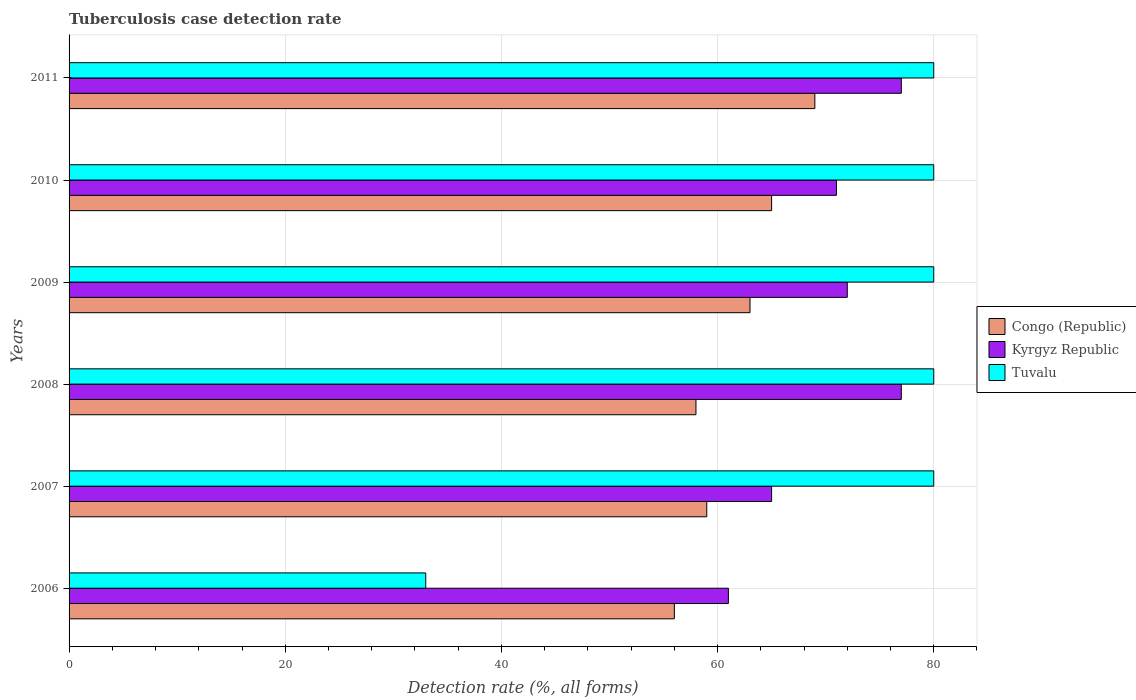How many different coloured bars are there?
Ensure brevity in your answer.  3. How many groups of bars are there?
Make the answer very short. 6. Are the number of bars per tick equal to the number of legend labels?
Keep it short and to the point. Yes. Are the number of bars on each tick of the Y-axis equal?
Provide a succinct answer. Yes. How many bars are there on the 3rd tick from the bottom?
Provide a succinct answer. 3. What is the label of the 4th group of bars from the top?
Make the answer very short. 2008. Across all years, what is the maximum tuberculosis case detection rate in in Kyrgyz Republic?
Your answer should be very brief. 77. Across all years, what is the minimum tuberculosis case detection rate in in Congo (Republic)?
Your answer should be very brief. 56. In which year was the tuberculosis case detection rate in in Tuvalu maximum?
Your response must be concise. 2007. In which year was the tuberculosis case detection rate in in Kyrgyz Republic minimum?
Give a very brief answer. 2006. What is the total tuberculosis case detection rate in in Tuvalu in the graph?
Keep it short and to the point. 433. What is the difference between the tuberculosis case detection rate in in Tuvalu in 2006 and the tuberculosis case detection rate in in Kyrgyz Republic in 2009?
Your answer should be very brief. -39. What is the average tuberculosis case detection rate in in Congo (Republic) per year?
Your answer should be very brief. 61.67. What is the ratio of the tuberculosis case detection rate in in Congo (Republic) in 2006 to that in 2007?
Keep it short and to the point. 0.95. What is the difference between the highest and the second highest tuberculosis case detection rate in in Congo (Republic)?
Your answer should be very brief. 4. What is the difference between the highest and the lowest tuberculosis case detection rate in in Congo (Republic)?
Keep it short and to the point. 13. In how many years, is the tuberculosis case detection rate in in Kyrgyz Republic greater than the average tuberculosis case detection rate in in Kyrgyz Republic taken over all years?
Your answer should be very brief. 4. What does the 2nd bar from the top in 2007 represents?
Your answer should be compact. Kyrgyz Republic. What does the 3rd bar from the bottom in 2009 represents?
Your answer should be very brief. Tuvalu. Is it the case that in every year, the sum of the tuberculosis case detection rate in in Tuvalu and tuberculosis case detection rate in in Kyrgyz Republic is greater than the tuberculosis case detection rate in in Congo (Republic)?
Your answer should be compact. Yes. How many bars are there?
Make the answer very short. 18. Are all the bars in the graph horizontal?
Keep it short and to the point. Yes. What is the difference between two consecutive major ticks on the X-axis?
Provide a succinct answer. 20. Are the values on the major ticks of X-axis written in scientific E-notation?
Your response must be concise. No. Does the graph contain any zero values?
Ensure brevity in your answer.  No. Does the graph contain grids?
Make the answer very short. Yes. Where does the legend appear in the graph?
Your answer should be compact. Center right. What is the title of the graph?
Offer a terse response. Tuberculosis case detection rate. Does "European Union" appear as one of the legend labels in the graph?
Provide a short and direct response. No. What is the label or title of the X-axis?
Keep it short and to the point. Detection rate (%, all forms). What is the label or title of the Y-axis?
Give a very brief answer. Years. What is the Detection rate (%, all forms) of Kyrgyz Republic in 2006?
Your answer should be compact. 61. What is the Detection rate (%, all forms) in Tuvalu in 2006?
Ensure brevity in your answer.  33. What is the Detection rate (%, all forms) of Congo (Republic) in 2009?
Keep it short and to the point. 63. What is the Detection rate (%, all forms) of Kyrgyz Republic in 2009?
Ensure brevity in your answer.  72. What is the Detection rate (%, all forms) in Tuvalu in 2009?
Ensure brevity in your answer.  80. What is the Detection rate (%, all forms) in Kyrgyz Republic in 2010?
Your answer should be compact. 71. What is the Detection rate (%, all forms) of Tuvalu in 2011?
Make the answer very short. 80. Across all years, what is the maximum Detection rate (%, all forms) in Kyrgyz Republic?
Make the answer very short. 77. Across all years, what is the minimum Detection rate (%, all forms) in Tuvalu?
Make the answer very short. 33. What is the total Detection rate (%, all forms) in Congo (Republic) in the graph?
Your response must be concise. 370. What is the total Detection rate (%, all forms) in Kyrgyz Republic in the graph?
Provide a short and direct response. 423. What is the total Detection rate (%, all forms) of Tuvalu in the graph?
Offer a terse response. 433. What is the difference between the Detection rate (%, all forms) in Congo (Republic) in 2006 and that in 2007?
Your answer should be very brief. -3. What is the difference between the Detection rate (%, all forms) of Kyrgyz Republic in 2006 and that in 2007?
Keep it short and to the point. -4. What is the difference between the Detection rate (%, all forms) of Tuvalu in 2006 and that in 2007?
Give a very brief answer. -47. What is the difference between the Detection rate (%, all forms) in Kyrgyz Republic in 2006 and that in 2008?
Keep it short and to the point. -16. What is the difference between the Detection rate (%, all forms) of Tuvalu in 2006 and that in 2008?
Give a very brief answer. -47. What is the difference between the Detection rate (%, all forms) in Congo (Republic) in 2006 and that in 2009?
Make the answer very short. -7. What is the difference between the Detection rate (%, all forms) of Tuvalu in 2006 and that in 2009?
Your answer should be very brief. -47. What is the difference between the Detection rate (%, all forms) in Kyrgyz Republic in 2006 and that in 2010?
Offer a very short reply. -10. What is the difference between the Detection rate (%, all forms) in Tuvalu in 2006 and that in 2010?
Provide a short and direct response. -47. What is the difference between the Detection rate (%, all forms) of Tuvalu in 2006 and that in 2011?
Provide a short and direct response. -47. What is the difference between the Detection rate (%, all forms) in Congo (Republic) in 2007 and that in 2008?
Keep it short and to the point. 1. What is the difference between the Detection rate (%, all forms) in Kyrgyz Republic in 2007 and that in 2008?
Offer a terse response. -12. What is the difference between the Detection rate (%, all forms) in Congo (Republic) in 2007 and that in 2009?
Offer a terse response. -4. What is the difference between the Detection rate (%, all forms) in Kyrgyz Republic in 2007 and that in 2009?
Offer a terse response. -7. What is the difference between the Detection rate (%, all forms) in Tuvalu in 2007 and that in 2009?
Offer a very short reply. 0. What is the difference between the Detection rate (%, all forms) in Tuvalu in 2007 and that in 2010?
Offer a very short reply. 0. What is the difference between the Detection rate (%, all forms) of Congo (Republic) in 2007 and that in 2011?
Offer a terse response. -10. What is the difference between the Detection rate (%, all forms) of Kyrgyz Republic in 2007 and that in 2011?
Ensure brevity in your answer.  -12. What is the difference between the Detection rate (%, all forms) of Tuvalu in 2008 and that in 2009?
Keep it short and to the point. 0. What is the difference between the Detection rate (%, all forms) of Congo (Republic) in 2008 and that in 2010?
Offer a terse response. -7. What is the difference between the Detection rate (%, all forms) of Congo (Republic) in 2008 and that in 2011?
Provide a short and direct response. -11. What is the difference between the Detection rate (%, all forms) of Tuvalu in 2008 and that in 2011?
Keep it short and to the point. 0. What is the difference between the Detection rate (%, all forms) of Congo (Republic) in 2009 and that in 2011?
Provide a short and direct response. -6. What is the difference between the Detection rate (%, all forms) in Kyrgyz Republic in 2009 and that in 2011?
Your answer should be compact. -5. What is the difference between the Detection rate (%, all forms) of Tuvalu in 2009 and that in 2011?
Make the answer very short. 0. What is the difference between the Detection rate (%, all forms) in Congo (Republic) in 2010 and that in 2011?
Provide a succinct answer. -4. What is the difference between the Detection rate (%, all forms) of Tuvalu in 2010 and that in 2011?
Make the answer very short. 0. What is the difference between the Detection rate (%, all forms) of Kyrgyz Republic in 2006 and the Detection rate (%, all forms) of Tuvalu in 2007?
Ensure brevity in your answer.  -19. What is the difference between the Detection rate (%, all forms) of Congo (Republic) in 2006 and the Detection rate (%, all forms) of Kyrgyz Republic in 2008?
Offer a terse response. -21. What is the difference between the Detection rate (%, all forms) of Congo (Republic) in 2006 and the Detection rate (%, all forms) of Tuvalu in 2008?
Offer a terse response. -24. What is the difference between the Detection rate (%, all forms) of Kyrgyz Republic in 2006 and the Detection rate (%, all forms) of Tuvalu in 2009?
Keep it short and to the point. -19. What is the difference between the Detection rate (%, all forms) in Kyrgyz Republic in 2006 and the Detection rate (%, all forms) in Tuvalu in 2010?
Your answer should be very brief. -19. What is the difference between the Detection rate (%, all forms) of Congo (Republic) in 2006 and the Detection rate (%, all forms) of Kyrgyz Republic in 2011?
Offer a terse response. -21. What is the difference between the Detection rate (%, all forms) of Congo (Republic) in 2006 and the Detection rate (%, all forms) of Tuvalu in 2011?
Your response must be concise. -24. What is the difference between the Detection rate (%, all forms) in Congo (Republic) in 2007 and the Detection rate (%, all forms) in Kyrgyz Republic in 2009?
Provide a short and direct response. -13. What is the difference between the Detection rate (%, all forms) of Congo (Republic) in 2007 and the Detection rate (%, all forms) of Tuvalu in 2009?
Keep it short and to the point. -21. What is the difference between the Detection rate (%, all forms) in Kyrgyz Republic in 2007 and the Detection rate (%, all forms) in Tuvalu in 2009?
Ensure brevity in your answer.  -15. What is the difference between the Detection rate (%, all forms) of Kyrgyz Republic in 2007 and the Detection rate (%, all forms) of Tuvalu in 2010?
Your response must be concise. -15. What is the difference between the Detection rate (%, all forms) in Congo (Republic) in 2007 and the Detection rate (%, all forms) in Tuvalu in 2011?
Your response must be concise. -21. What is the difference between the Detection rate (%, all forms) of Congo (Republic) in 2008 and the Detection rate (%, all forms) of Kyrgyz Republic in 2009?
Give a very brief answer. -14. What is the difference between the Detection rate (%, all forms) in Kyrgyz Republic in 2008 and the Detection rate (%, all forms) in Tuvalu in 2009?
Provide a short and direct response. -3. What is the difference between the Detection rate (%, all forms) of Congo (Republic) in 2008 and the Detection rate (%, all forms) of Tuvalu in 2010?
Your answer should be very brief. -22. What is the difference between the Detection rate (%, all forms) of Congo (Republic) in 2008 and the Detection rate (%, all forms) of Tuvalu in 2011?
Your answer should be very brief. -22. What is the difference between the Detection rate (%, all forms) in Kyrgyz Republic in 2008 and the Detection rate (%, all forms) in Tuvalu in 2011?
Provide a short and direct response. -3. What is the difference between the Detection rate (%, all forms) in Congo (Republic) in 2009 and the Detection rate (%, all forms) in Tuvalu in 2010?
Provide a succinct answer. -17. What is the difference between the Detection rate (%, all forms) in Congo (Republic) in 2009 and the Detection rate (%, all forms) in Kyrgyz Republic in 2011?
Give a very brief answer. -14. What is the difference between the Detection rate (%, all forms) of Congo (Republic) in 2010 and the Detection rate (%, all forms) of Kyrgyz Republic in 2011?
Make the answer very short. -12. What is the average Detection rate (%, all forms) of Congo (Republic) per year?
Keep it short and to the point. 61.67. What is the average Detection rate (%, all forms) of Kyrgyz Republic per year?
Make the answer very short. 70.5. What is the average Detection rate (%, all forms) of Tuvalu per year?
Your response must be concise. 72.17. In the year 2006, what is the difference between the Detection rate (%, all forms) of Congo (Republic) and Detection rate (%, all forms) of Kyrgyz Republic?
Your answer should be very brief. -5. In the year 2007, what is the difference between the Detection rate (%, all forms) in Kyrgyz Republic and Detection rate (%, all forms) in Tuvalu?
Offer a very short reply. -15. In the year 2008, what is the difference between the Detection rate (%, all forms) in Congo (Republic) and Detection rate (%, all forms) in Kyrgyz Republic?
Provide a succinct answer. -19. In the year 2009, what is the difference between the Detection rate (%, all forms) in Congo (Republic) and Detection rate (%, all forms) in Kyrgyz Republic?
Provide a succinct answer. -9. In the year 2009, what is the difference between the Detection rate (%, all forms) of Congo (Republic) and Detection rate (%, all forms) of Tuvalu?
Ensure brevity in your answer.  -17. In the year 2010, what is the difference between the Detection rate (%, all forms) of Congo (Republic) and Detection rate (%, all forms) of Tuvalu?
Your response must be concise. -15. In the year 2011, what is the difference between the Detection rate (%, all forms) of Congo (Republic) and Detection rate (%, all forms) of Kyrgyz Republic?
Offer a terse response. -8. In the year 2011, what is the difference between the Detection rate (%, all forms) of Congo (Republic) and Detection rate (%, all forms) of Tuvalu?
Offer a very short reply. -11. In the year 2011, what is the difference between the Detection rate (%, all forms) in Kyrgyz Republic and Detection rate (%, all forms) in Tuvalu?
Offer a very short reply. -3. What is the ratio of the Detection rate (%, all forms) of Congo (Republic) in 2006 to that in 2007?
Your answer should be very brief. 0.95. What is the ratio of the Detection rate (%, all forms) in Kyrgyz Republic in 2006 to that in 2007?
Keep it short and to the point. 0.94. What is the ratio of the Detection rate (%, all forms) of Tuvalu in 2006 to that in 2007?
Ensure brevity in your answer.  0.41. What is the ratio of the Detection rate (%, all forms) of Congo (Republic) in 2006 to that in 2008?
Make the answer very short. 0.97. What is the ratio of the Detection rate (%, all forms) of Kyrgyz Republic in 2006 to that in 2008?
Make the answer very short. 0.79. What is the ratio of the Detection rate (%, all forms) of Tuvalu in 2006 to that in 2008?
Your answer should be compact. 0.41. What is the ratio of the Detection rate (%, all forms) of Kyrgyz Republic in 2006 to that in 2009?
Offer a very short reply. 0.85. What is the ratio of the Detection rate (%, all forms) of Tuvalu in 2006 to that in 2009?
Provide a short and direct response. 0.41. What is the ratio of the Detection rate (%, all forms) in Congo (Republic) in 2006 to that in 2010?
Ensure brevity in your answer.  0.86. What is the ratio of the Detection rate (%, all forms) of Kyrgyz Republic in 2006 to that in 2010?
Offer a terse response. 0.86. What is the ratio of the Detection rate (%, all forms) in Tuvalu in 2006 to that in 2010?
Provide a short and direct response. 0.41. What is the ratio of the Detection rate (%, all forms) of Congo (Republic) in 2006 to that in 2011?
Make the answer very short. 0.81. What is the ratio of the Detection rate (%, all forms) in Kyrgyz Republic in 2006 to that in 2011?
Offer a very short reply. 0.79. What is the ratio of the Detection rate (%, all forms) in Tuvalu in 2006 to that in 2011?
Offer a terse response. 0.41. What is the ratio of the Detection rate (%, all forms) of Congo (Republic) in 2007 to that in 2008?
Ensure brevity in your answer.  1.02. What is the ratio of the Detection rate (%, all forms) in Kyrgyz Republic in 2007 to that in 2008?
Offer a terse response. 0.84. What is the ratio of the Detection rate (%, all forms) of Congo (Republic) in 2007 to that in 2009?
Offer a very short reply. 0.94. What is the ratio of the Detection rate (%, all forms) of Kyrgyz Republic in 2007 to that in 2009?
Your answer should be compact. 0.9. What is the ratio of the Detection rate (%, all forms) of Tuvalu in 2007 to that in 2009?
Keep it short and to the point. 1. What is the ratio of the Detection rate (%, all forms) in Congo (Republic) in 2007 to that in 2010?
Give a very brief answer. 0.91. What is the ratio of the Detection rate (%, all forms) of Kyrgyz Republic in 2007 to that in 2010?
Give a very brief answer. 0.92. What is the ratio of the Detection rate (%, all forms) of Congo (Republic) in 2007 to that in 2011?
Give a very brief answer. 0.86. What is the ratio of the Detection rate (%, all forms) in Kyrgyz Republic in 2007 to that in 2011?
Your answer should be very brief. 0.84. What is the ratio of the Detection rate (%, all forms) of Congo (Republic) in 2008 to that in 2009?
Make the answer very short. 0.92. What is the ratio of the Detection rate (%, all forms) in Kyrgyz Republic in 2008 to that in 2009?
Offer a terse response. 1.07. What is the ratio of the Detection rate (%, all forms) in Congo (Republic) in 2008 to that in 2010?
Offer a very short reply. 0.89. What is the ratio of the Detection rate (%, all forms) of Kyrgyz Republic in 2008 to that in 2010?
Make the answer very short. 1.08. What is the ratio of the Detection rate (%, all forms) in Tuvalu in 2008 to that in 2010?
Your answer should be very brief. 1. What is the ratio of the Detection rate (%, all forms) in Congo (Republic) in 2008 to that in 2011?
Provide a succinct answer. 0.84. What is the ratio of the Detection rate (%, all forms) of Kyrgyz Republic in 2008 to that in 2011?
Make the answer very short. 1. What is the ratio of the Detection rate (%, all forms) in Tuvalu in 2008 to that in 2011?
Provide a succinct answer. 1. What is the ratio of the Detection rate (%, all forms) in Congo (Republic) in 2009 to that in 2010?
Offer a very short reply. 0.97. What is the ratio of the Detection rate (%, all forms) of Kyrgyz Republic in 2009 to that in 2010?
Your answer should be compact. 1.01. What is the ratio of the Detection rate (%, all forms) in Tuvalu in 2009 to that in 2010?
Make the answer very short. 1. What is the ratio of the Detection rate (%, all forms) of Congo (Republic) in 2009 to that in 2011?
Your response must be concise. 0.91. What is the ratio of the Detection rate (%, all forms) in Kyrgyz Republic in 2009 to that in 2011?
Make the answer very short. 0.94. What is the ratio of the Detection rate (%, all forms) of Congo (Republic) in 2010 to that in 2011?
Ensure brevity in your answer.  0.94. What is the ratio of the Detection rate (%, all forms) of Kyrgyz Republic in 2010 to that in 2011?
Offer a very short reply. 0.92. What is the difference between the highest and the second highest Detection rate (%, all forms) in Congo (Republic)?
Your answer should be compact. 4. What is the difference between the highest and the lowest Detection rate (%, all forms) in Tuvalu?
Provide a succinct answer. 47. 